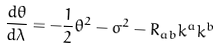Convert formula to latex. <formula><loc_0><loc_0><loc_500><loc_500>\frac { d \theta } { d \lambda } = - \frac { 1 } { 2 } \theta ^ { 2 } - \sigma ^ { 2 } - R _ { a b } k ^ { a } k ^ { b }</formula> 